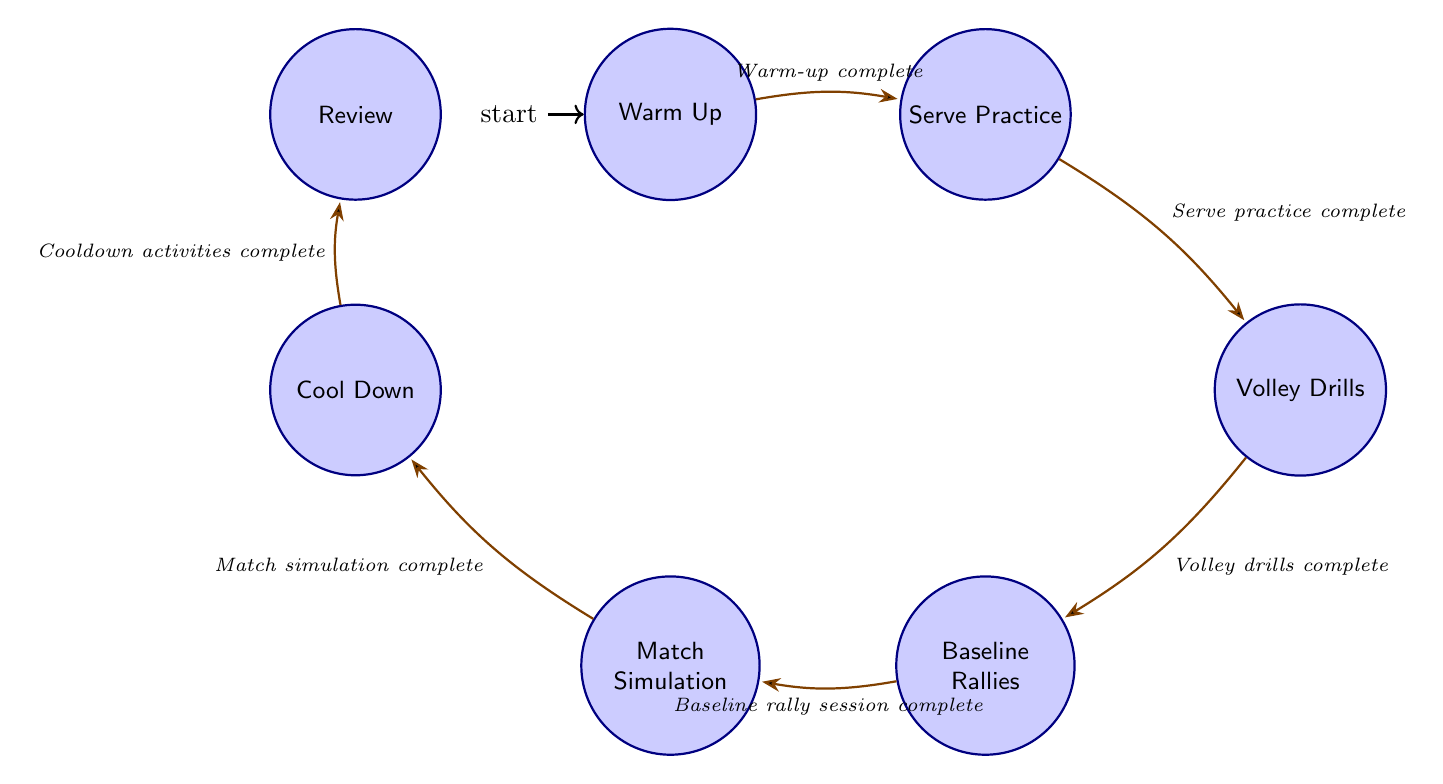What is the starting state of the training routine? The initial state indicated in the diagram is "Warm Up," which is where the training routine begins.
Answer: Warm Up How many states are there in the training routine? By counting the individual nodes in the diagram, there are a total of seven distinct states.
Answer: 7 What is the last state in the routine? The final state that is reached at the end of the training routine is "Review," which occurs after the cooldown activities.
Answer: Review Which state follows "Baseline Rallies"? According to the transitions in the diagram, "Match Simulation" is the state that directly follows "Baseline Rallies" once the baseline rally session is complete.
Answer: Match Simulation What activity completes the "Cool Down" state? The transition indicated in the diagram states that once the cooldown activities are complete, the routine moves to the "Review" state.
Answer: Cooldown activities complete What condition leads from "Volley Drills" to "Baseline Rallies"? The transition from "Volley Drills" to "Baseline Rallies" is contingent upon the completion of "Volley drills" as per the flow of the diagram.
Answer: Volley drills complete What is the relationship between "Serve Practice" and "Volley Drills"? The relationship is a direct transition where "Serve Practice" leads to "Volley Drills" once the condition "Serve practice complete" is met.
Answer: Transition What is the first transition after "Warm Up"? The first transition occurs from "Warm Up" to "Serve Practice" when the condition "Warm-up complete" is satisfied.
Answer: Serve Practice What is the sequence of states after "Match Simulation"? After "Match Simulation," the sequence follows directly to "Cool Down," culminating with "Review" after completing the cooldown activities.
Answer: Cool Down, Review 